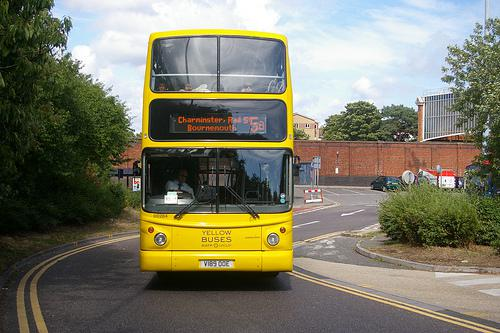Question: what color is this bus?
Choices:
A. Orange.
B. Red.
C. Yellow.
D. Silver.
Answer with the letter. Answer: C Question: who is on the bus?
Choices:
A. People.
B. Passengers.
C. Men.
D. Women.
Answer with the letter. Answer: B Question: what kind of bus is this?
Choices:
A. One that moves.
B. A big one.
C. Double decker.
D. A red one.
Answer with the letter. Answer: C Question: what is in the background?
Choices:
A. A tower.
B. A building.
C. Apartments.
D. Bank.
Answer with the letter. Answer: B Question: how does the sky appear?
Choices:
A. Hazy.
B. Lots of clouds.
C. Not clear.
D. Cloudy.
Answer with the letter. Answer: D Question: what color is the driver wearing?
Choices:
A. White.
B. Black.
C. Orange.
D. Grey.
Answer with the letter. Answer: A 